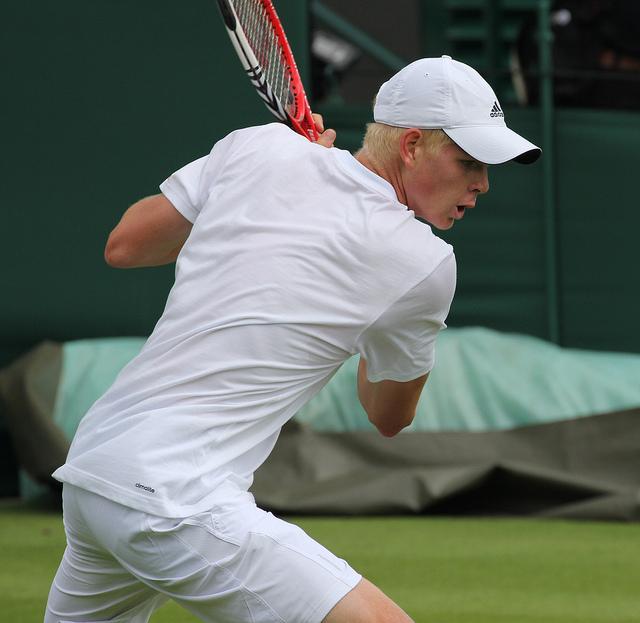What color is the person wearing?
Concise answer only. White. What team is he playing?
Be succinct. Tennis. Who will win this game?
Short answer required. Man. What is the man holding?
Short answer required. Racket. Does the man have blonde hair?
Keep it brief. Yes. What does the man have in his hands?
Give a very brief answer. Tennis racket. Is this person wearing a hat?
Quick response, please. Yes. What is the man wearing on his head?
Be succinct. Hat. Is this sport called baseball?
Short answer required. No. Is this a a famous tennis player?
Answer briefly. No. 